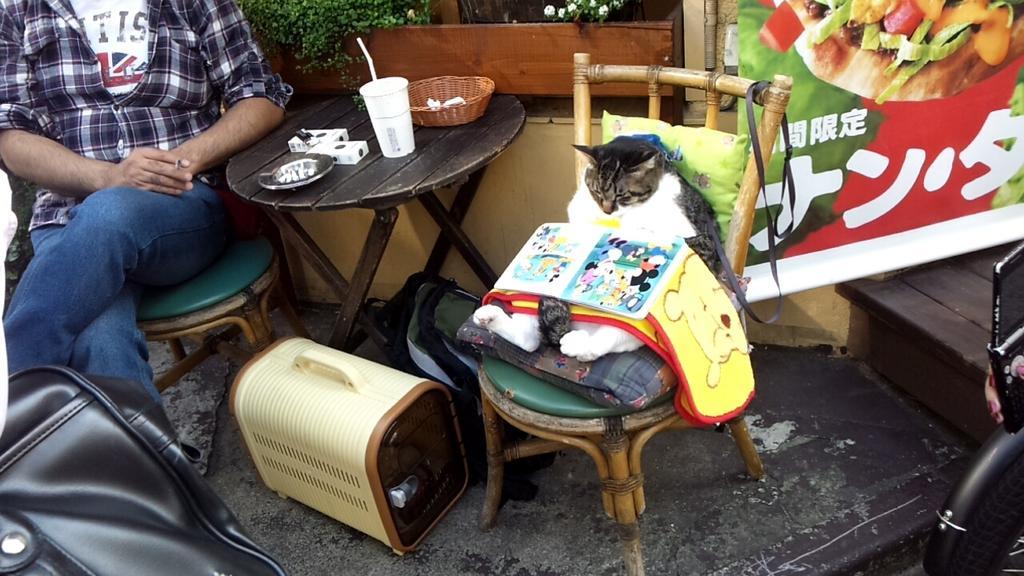Could you give a brief overview of what you see in this image? In this image i can see a person wearing a white t shirt, shirt and blue jeans sitting on the chair and a cat sitting on the chair in front of a table. On the table i can see a cup, a basket and few other objects. I can see a leather bag, a cat house and a bag on the cat. In the background i can see few plants and a banner. 